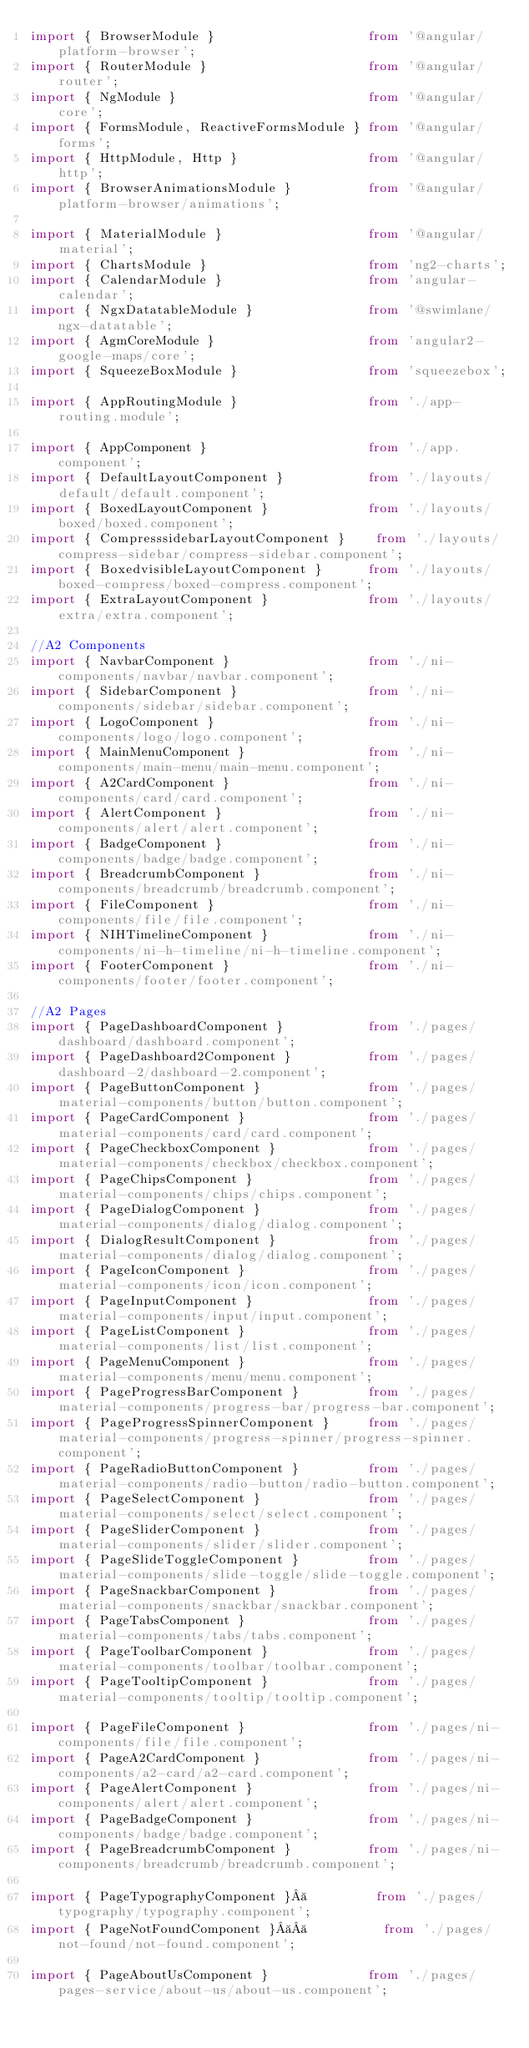Convert code to text. <code><loc_0><loc_0><loc_500><loc_500><_TypeScript_>import { BrowserModule }                    from '@angular/platform-browser';
import { RouterModule }                     from '@angular/router';
import { NgModule }                         from '@angular/core';
import { FormsModule, ReactiveFormsModule } from '@angular/forms';
import { HttpModule, Http }                 from '@angular/http';
import { BrowserAnimationsModule }          from '@angular/platform-browser/animations';

import { MaterialModule }                   from '@angular/material';
import { ChartsModule }                     from 'ng2-charts';
import { CalendarModule }                   from 'angular-calendar';
import { NgxDatatableModule }               from '@swimlane/ngx-datatable';
import { AgmCoreModule }                    from 'angular2-google-maps/core';
import { SqueezeBoxModule }                 from 'squeezebox';

import { AppRoutingModule }                 from './app-routing.module';

import { AppComponent }                     from './app.component';
import { DefaultLayoutComponent }           from './layouts/default/default.component';
import { BoxedLayoutComponent }             from './layouts/boxed/boxed.component';
import { CompresssidebarLayoutComponent }    from './layouts/compress-sidebar/compress-sidebar.component';
import { BoxedvisibleLayoutComponent }      from './layouts/boxed-compress/boxed-compress.component';
import { ExtraLayoutComponent }             from './layouts/extra/extra.component';

//A2 Components
import { NavbarComponent }                  from './ni-components/navbar/navbar.component';
import { SidebarComponent }                 from './ni-components/sidebar/sidebar.component';
import { LogoComponent }                    from './ni-components/logo/logo.component';
import { MainMenuComponent }                from './ni-components/main-menu/main-menu.component';
import { A2CardComponent }                  from './ni-components/card/card.component';
import { AlertComponent }                   from './ni-components/alert/alert.component';
import { BadgeComponent }                   from './ni-components/badge/badge.component';
import { BreadcrumbComponent }              from './ni-components/breadcrumb/breadcrumb.component';
import { FileComponent }                    from './ni-components/file/file.component';
import { NIHTimelineComponent }             from './ni-components/ni-h-timeline/ni-h-timeline.component';
import { FooterComponent }                  from './ni-components/footer/footer.component';

//A2 Pages
import { PageDashboardComponent }           from './pages/dashboard/dashboard.component';
import { PageDashboard2Component }          from './pages/dashboard-2/dashboard-2.component';
import { PageButtonComponent }              from './pages/material-components/button/button.component';
import { PageCardComponent }                from './pages/material-components/card/card.component';
import { PageCheckboxComponent }            from './pages/material-components/checkbox/checkbox.component';
import { PageChipsComponent }               from './pages/material-components/chips/chips.component';
import { PageDialogComponent }              from './pages/material-components/dialog/dialog.component';
import { DialogResultComponent }            from './pages/material-components/dialog/dialog.component';
import { PageIconComponent }                from './pages/material-components/icon/icon.component';
import { PageInputComponent }               from './pages/material-components/input/input.component';
import { PageListComponent }                from './pages/material-components/list/list.component';
import { PageMenuComponent }                from './pages/material-components/menu/menu.component';
import { PageProgressBarComponent }         from './pages/material-components/progress-bar/progress-bar.component';
import { PageProgressSpinnerComponent }     from './pages/material-components/progress-spinner/progress-spinner.component';
import { PageRadioButtonComponent }         from './pages/material-components/radio-button/radio-button.component';
import { PageSelectComponent }              from './pages/material-components/select/select.component';
import { PageSliderComponent }              from './pages/material-components/slider/slider.component';
import { PageSlideToggleComponent }         from './pages/material-components/slide-toggle/slide-toggle.component';
import { PageSnackbarComponent }            from './pages/material-components/snackbar/snackbar.component';
import { PageTabsComponent }                from './pages/material-components/tabs/tabs.component';
import { PageToolbarComponent }             from './pages/material-components/toolbar/toolbar.component';
import { PageTooltipComponent }             from './pages/material-components/tooltip/tooltip.component';

import { PageFileComponent }                from './pages/ni-components/file/file.component';
import { PageA2CardComponent }              from './pages/ni-components/a2-card/a2-card.component';
import { PageAlertComponent }               from './pages/ni-components/alert/alert.component';
import { PageBadgeComponent }               from './pages/ni-components/badge/badge.component';
import { PageBreadcrumbComponent }          from './pages/ni-components/breadcrumb/breadcrumb.component';

import { PageTypographyComponent }          from './pages/typography/typography.component';
import { PageNotFoundComponent }            from './pages/not-found/not-found.component';

import { PageAboutUsComponent }             from './pages/pages-service/about-us/about-us.component';</code> 